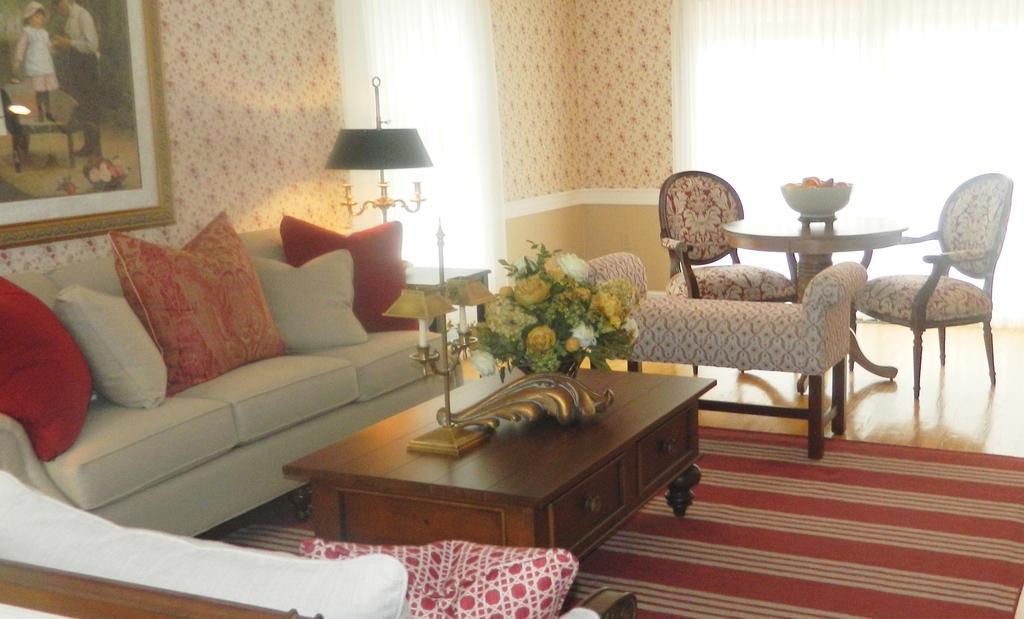Can you describe this image briefly? On the left it's a sofa in the middle it's a table there are chairs in the right and mat in the down. 